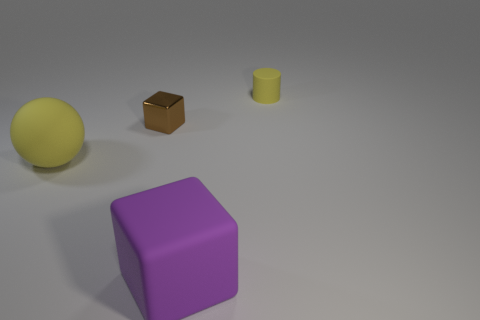Add 3 big yellow matte spheres. How many objects exist? 7 Add 3 purple matte blocks. How many purple matte blocks are left? 4 Add 2 yellow matte things. How many yellow matte things exist? 4 Subtract 0 blue balls. How many objects are left? 4 Subtract all matte things. Subtract all tiny yellow things. How many objects are left? 0 